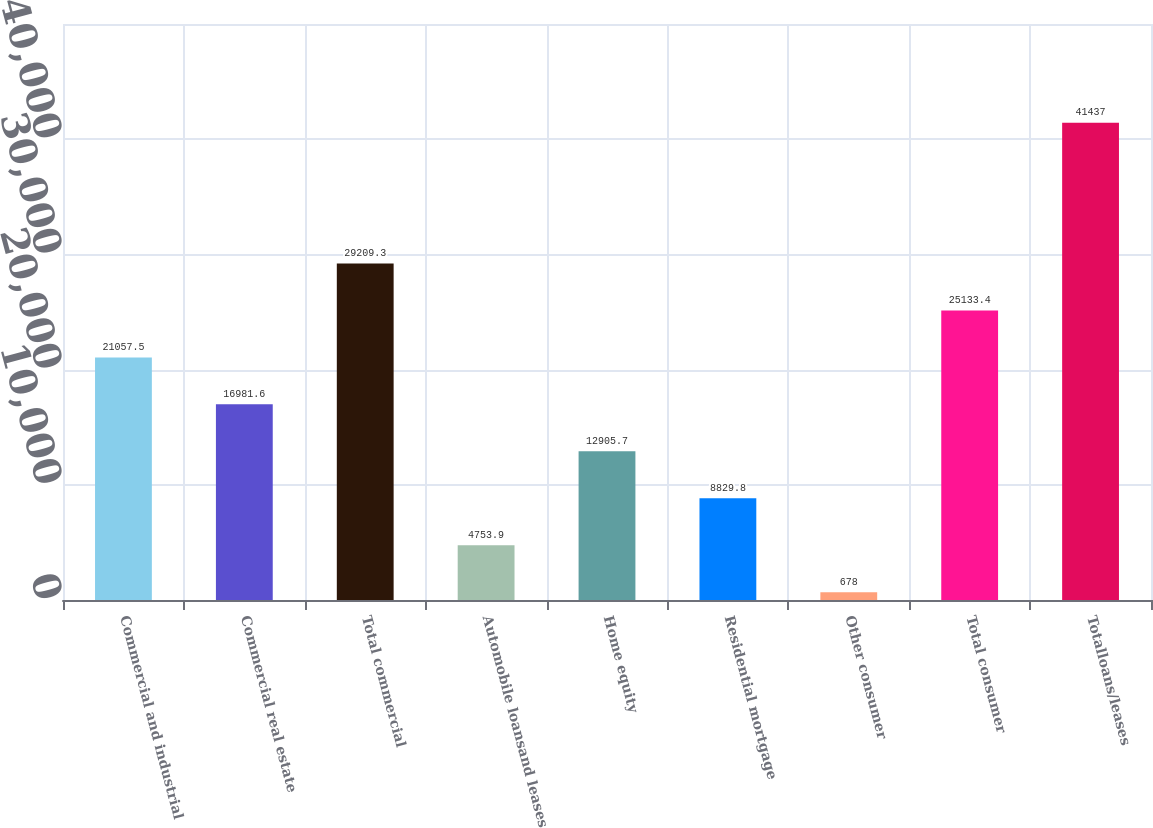Convert chart. <chart><loc_0><loc_0><loc_500><loc_500><bar_chart><fcel>Commercial and industrial<fcel>Commercial real estate<fcel>Total commercial<fcel>Automobile loansand leases<fcel>Home equity<fcel>Residential mortgage<fcel>Other consumer<fcel>Total consumer<fcel>Totalloans/leases<nl><fcel>21057.5<fcel>16981.6<fcel>29209.3<fcel>4753.9<fcel>12905.7<fcel>8829.8<fcel>678<fcel>25133.4<fcel>41437<nl></chart> 